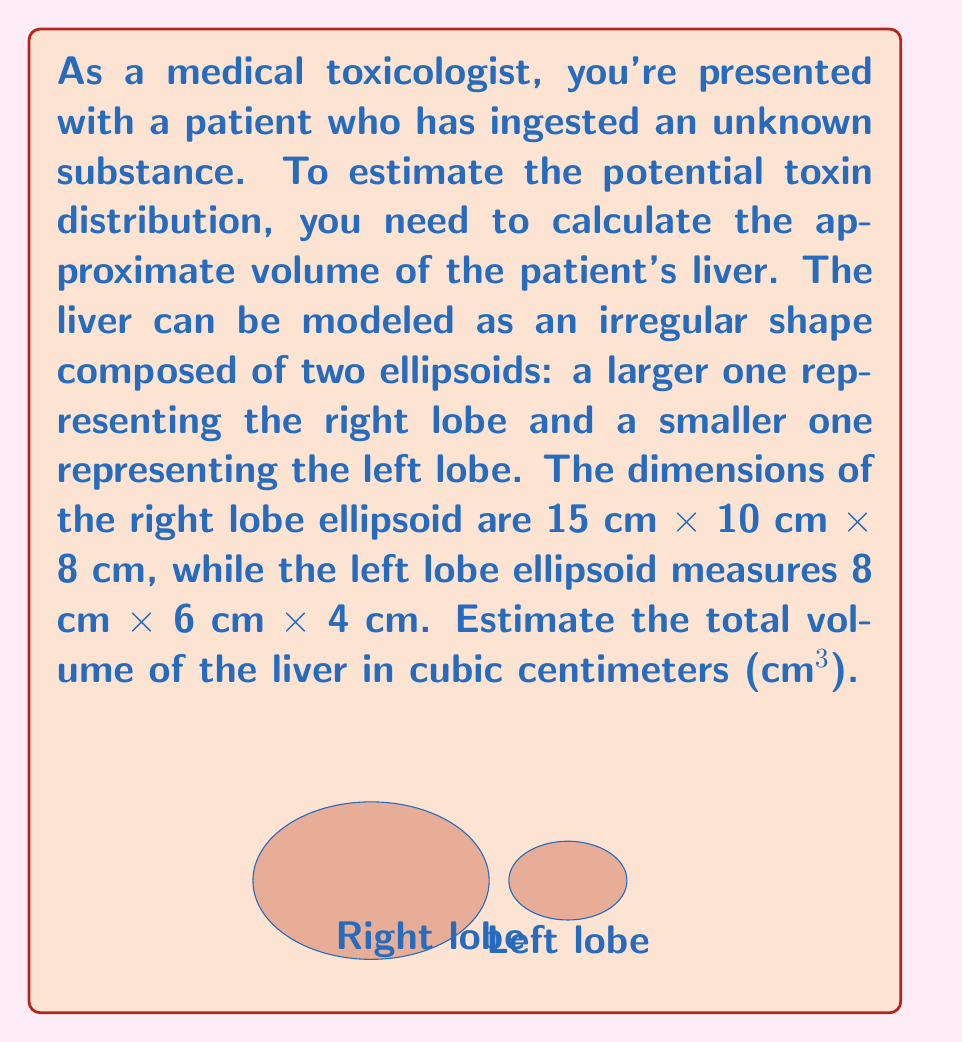Solve this math problem. To solve this problem, we'll follow these steps:

1) The volume of an ellipsoid is given by the formula:

   $$V = \frac{4}{3}\pi abc$$

   where $a$, $b$, and $c$ are the semi-axes lengths.

2) For the right lobe:
   $a = 7.5$ cm, $b = 5$ cm, $c = 4$ cm
   
   $$V_r = \frac{4}{3}\pi (7.5)(5)(4) = \frac{4}{3}\pi (150) \approx 628.32 \text{ cm}^3$$

3) For the left lobe:
   $a = 4$ cm, $b = 3$ cm, $c = 2$ cm
   
   $$V_l = \frac{4}{3}\pi (4)(3)(2) = \frac{4}{3}\pi (24) \approx 100.53 \text{ cm}^3$$

4) The total volume is the sum of both lobes:

   $$V_{\text{total}} = V_r + V_l \approx 628.32 + 100.53 = 728.85 \text{ cm}^3$$

5) Rounding to the nearest whole number:

   $$V_{\text{total}} \approx 729 \text{ cm}^3$$

This estimation provides a reasonable approximation of the liver's volume, which is crucial for assessing potential toxin distribution and determining appropriate treatment strategies.
Answer: 729 cm³ 